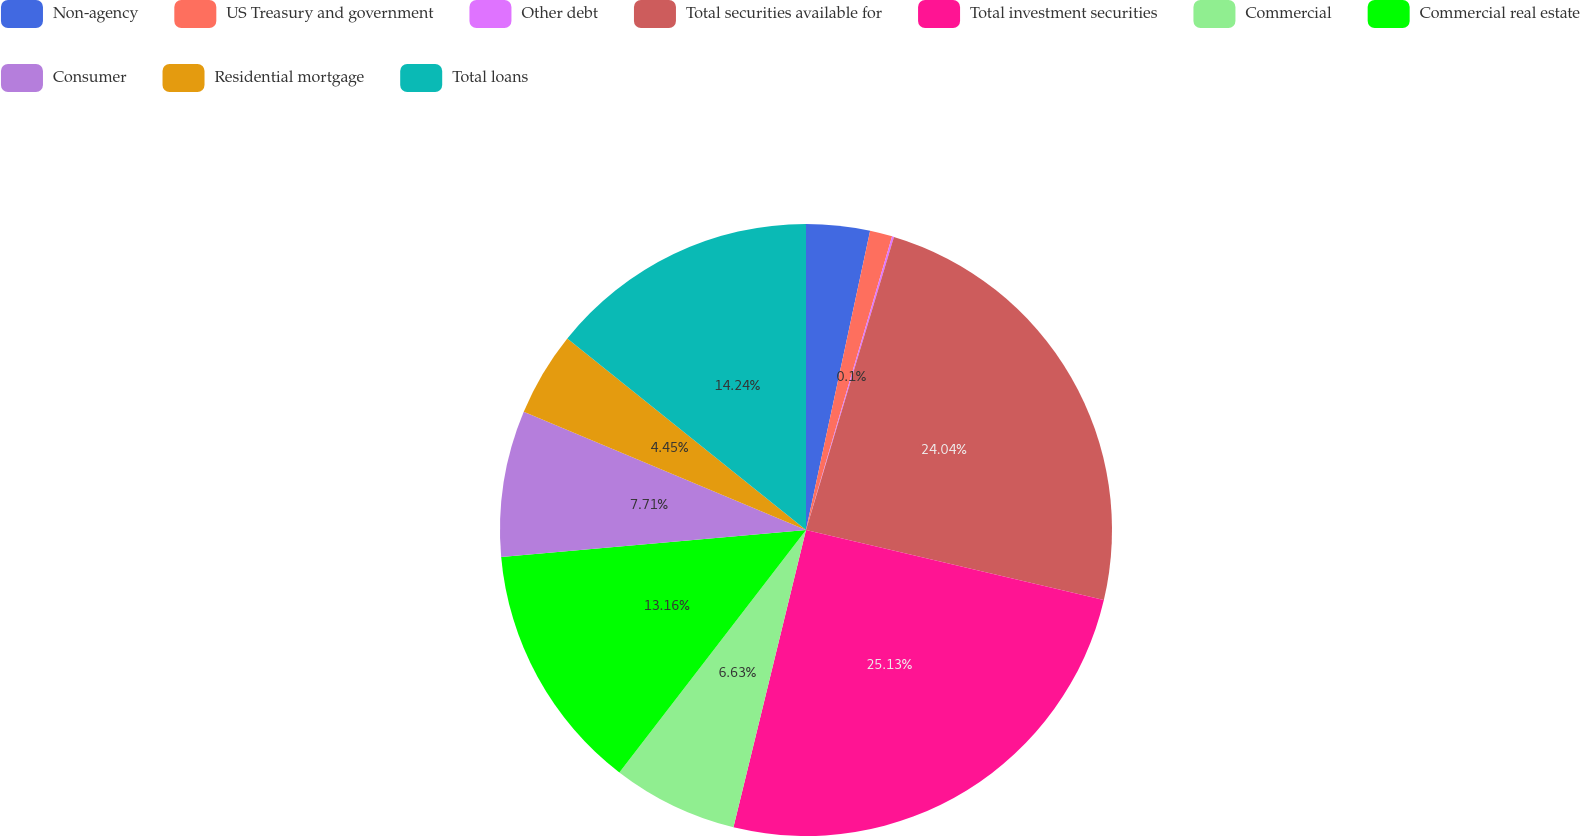<chart> <loc_0><loc_0><loc_500><loc_500><pie_chart><fcel>Non-agency<fcel>US Treasury and government<fcel>Other debt<fcel>Total securities available for<fcel>Total investment securities<fcel>Commercial<fcel>Commercial real estate<fcel>Consumer<fcel>Residential mortgage<fcel>Total loans<nl><fcel>3.36%<fcel>1.18%<fcel>0.1%<fcel>24.04%<fcel>25.13%<fcel>6.63%<fcel>13.16%<fcel>7.71%<fcel>4.45%<fcel>14.24%<nl></chart> 